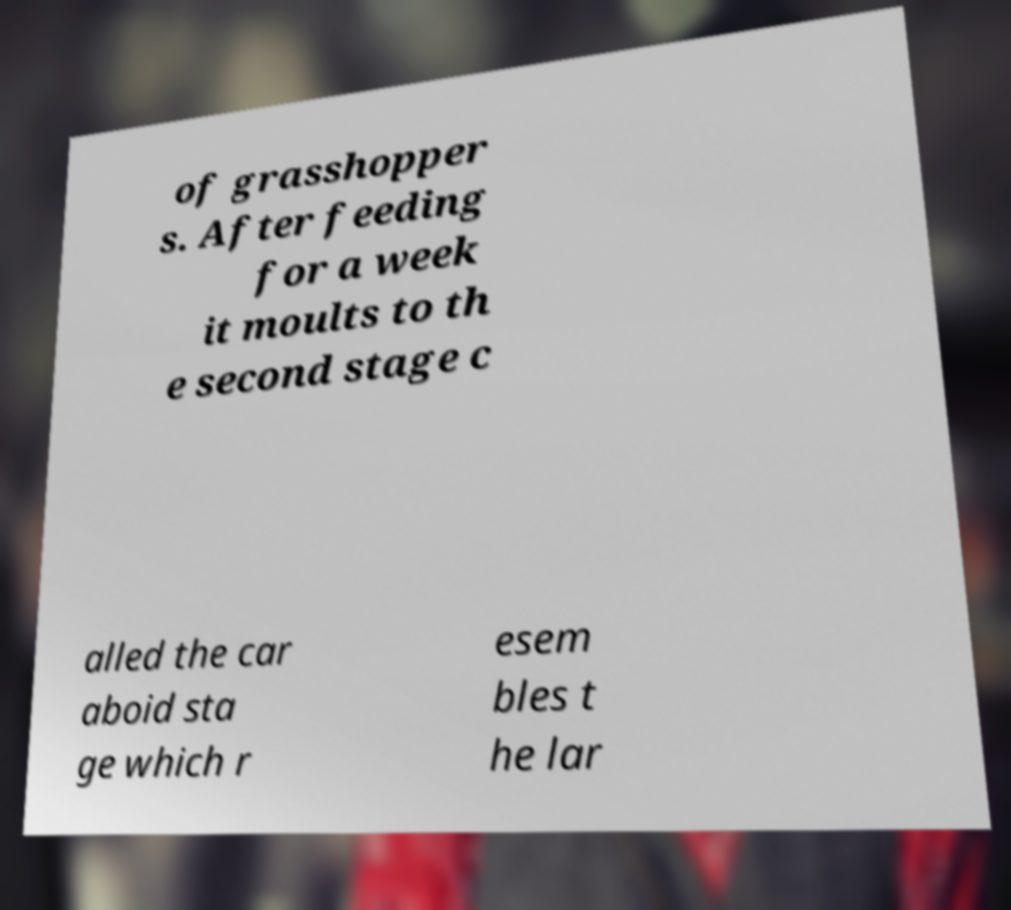I need the written content from this picture converted into text. Can you do that? of grasshopper s. After feeding for a week it moults to th e second stage c alled the car aboid sta ge which r esem bles t he lar 